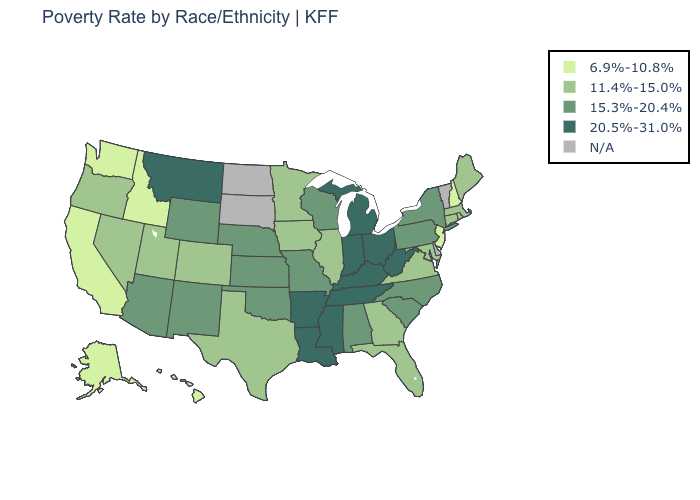What is the highest value in states that border Wyoming?
Be succinct. 20.5%-31.0%. Which states have the highest value in the USA?
Write a very short answer. Arkansas, Indiana, Kentucky, Louisiana, Michigan, Mississippi, Montana, Ohio, Tennessee, West Virginia. How many symbols are there in the legend?
Quick response, please. 5. What is the value of Louisiana?
Keep it brief. 20.5%-31.0%. Name the states that have a value in the range 11.4%-15.0%?
Short answer required. Colorado, Connecticut, Florida, Georgia, Illinois, Iowa, Maine, Maryland, Massachusetts, Minnesota, Nevada, Oregon, Rhode Island, Texas, Utah, Virginia. What is the value of Wisconsin?
Be succinct. 15.3%-20.4%. What is the highest value in states that border Idaho?
Short answer required. 20.5%-31.0%. What is the highest value in the West ?
Give a very brief answer. 20.5%-31.0%. Name the states that have a value in the range 15.3%-20.4%?
Quick response, please. Alabama, Arizona, Kansas, Missouri, Nebraska, New Mexico, New York, North Carolina, Oklahoma, Pennsylvania, South Carolina, Wisconsin, Wyoming. Name the states that have a value in the range N/A?
Keep it brief. Delaware, North Dakota, South Dakota, Vermont. Which states have the lowest value in the USA?
Answer briefly. Alaska, California, Hawaii, Idaho, New Hampshire, New Jersey, Washington. How many symbols are there in the legend?
Write a very short answer. 5. What is the value of New Jersey?
Answer briefly. 6.9%-10.8%. What is the value of Missouri?
Answer briefly. 15.3%-20.4%. 